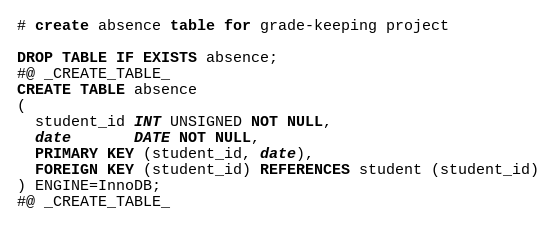<code> <loc_0><loc_0><loc_500><loc_500><_SQL_># create absence table for grade-keeping project

DROP TABLE IF EXISTS absence;
#@ _CREATE_TABLE_
CREATE TABLE absence
(
  student_id INT UNSIGNED NOT NULL,
  date       DATE NOT NULL,
  PRIMARY KEY (student_id, date),
  FOREIGN KEY (student_id) REFERENCES student (student_id)
) ENGINE=InnoDB;
#@ _CREATE_TABLE_
</code> 